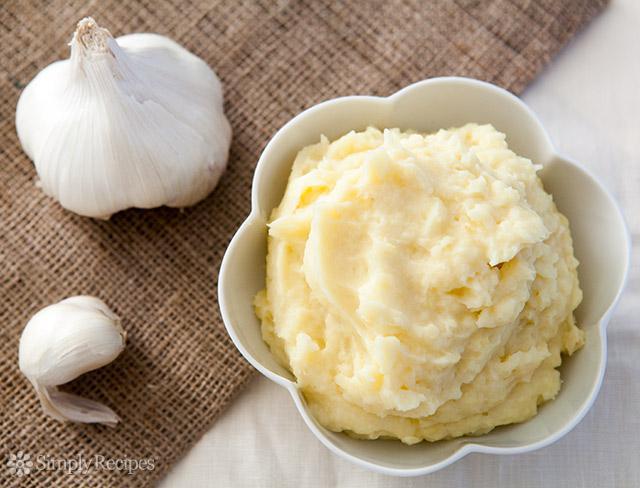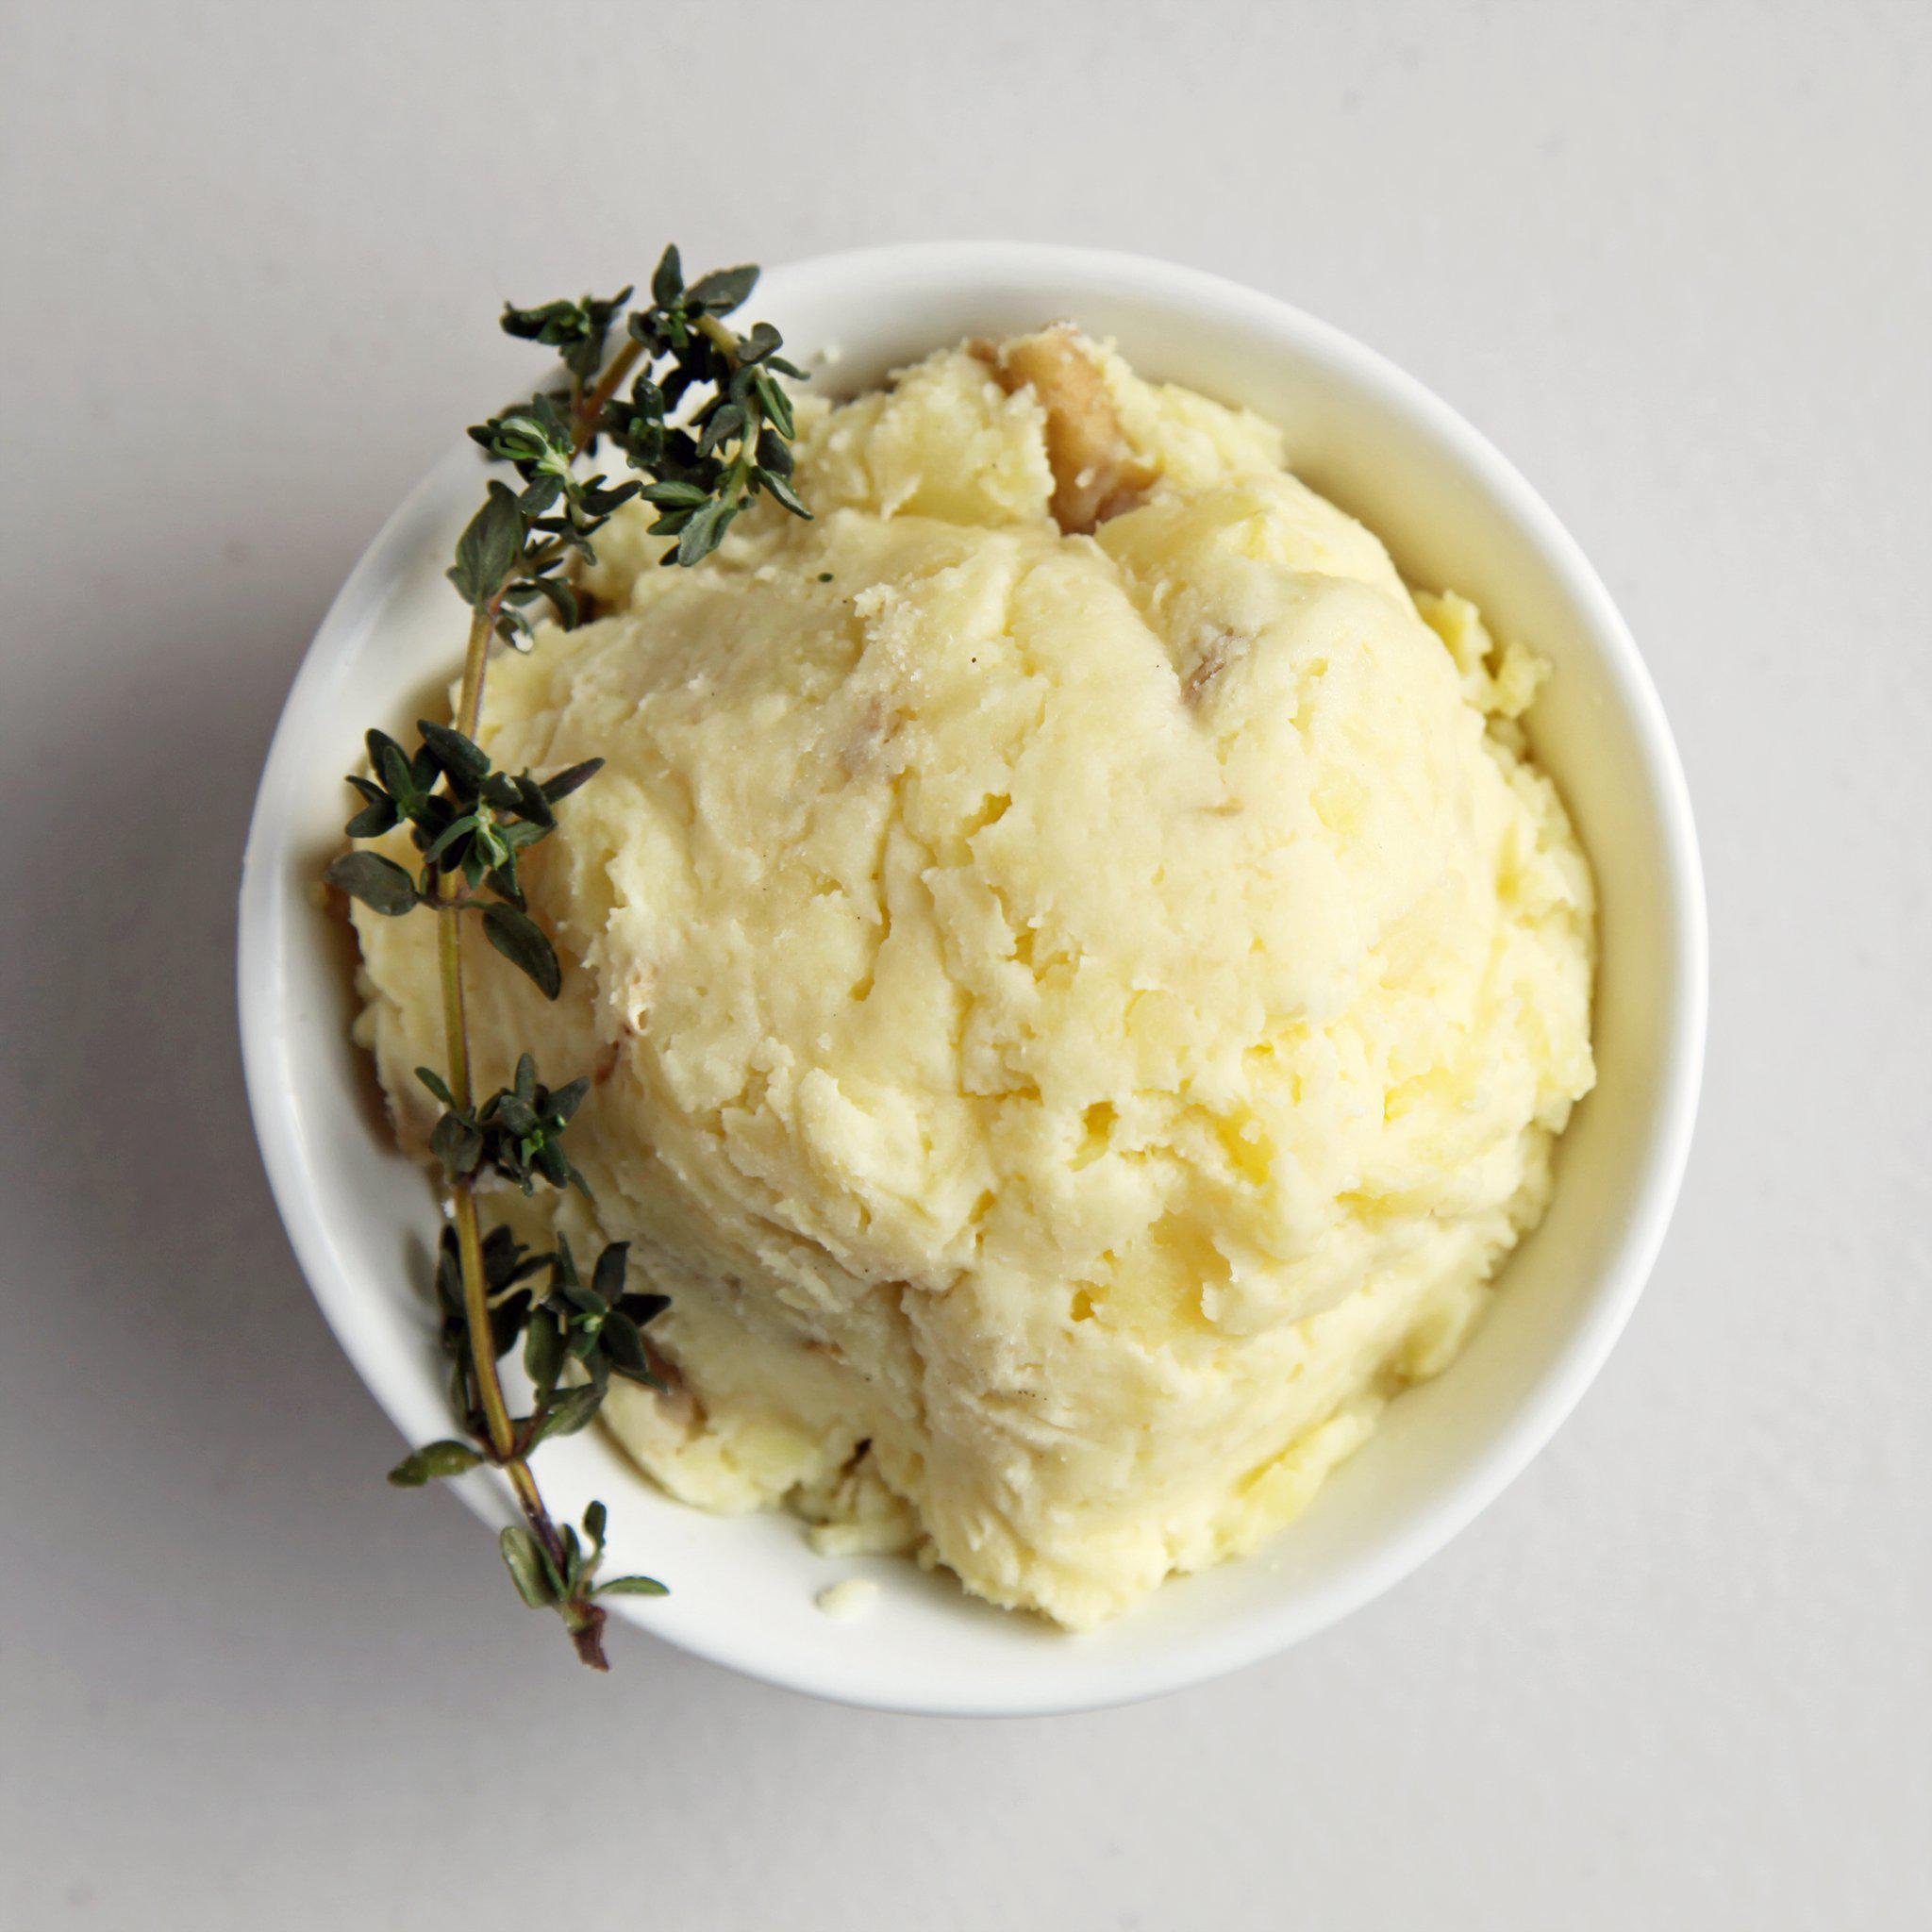The first image is the image on the left, the second image is the image on the right. Considering the images on both sides, is "One bowl of mashed potatoes is garnished with a green sprig and the other bowl appears ungarnished." valid? Answer yes or no. Yes. The first image is the image on the left, the second image is the image on the right. Assess this claim about the two images: "At least one of the bowls is white.". Correct or not? Answer yes or no. Yes. The first image is the image on the left, the second image is the image on the right. For the images displayed, is the sentence "the bowl on the left image is all white" factually correct? Answer yes or no. Yes. 